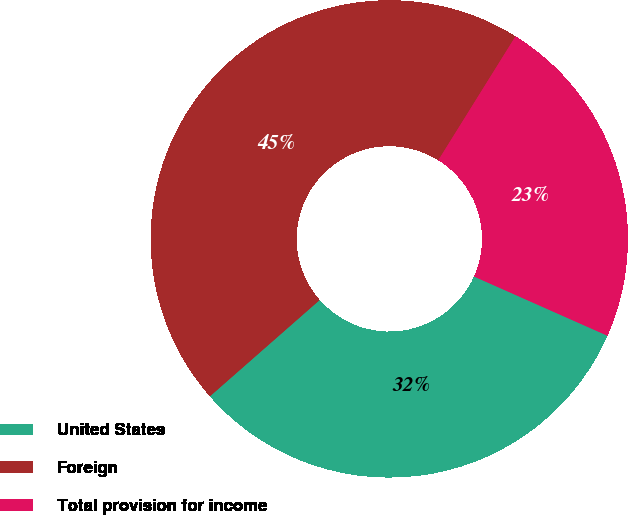<chart> <loc_0><loc_0><loc_500><loc_500><pie_chart><fcel>United States<fcel>Foreign<fcel>Total provision for income<nl><fcel>31.89%<fcel>45.33%<fcel>22.78%<nl></chart> 